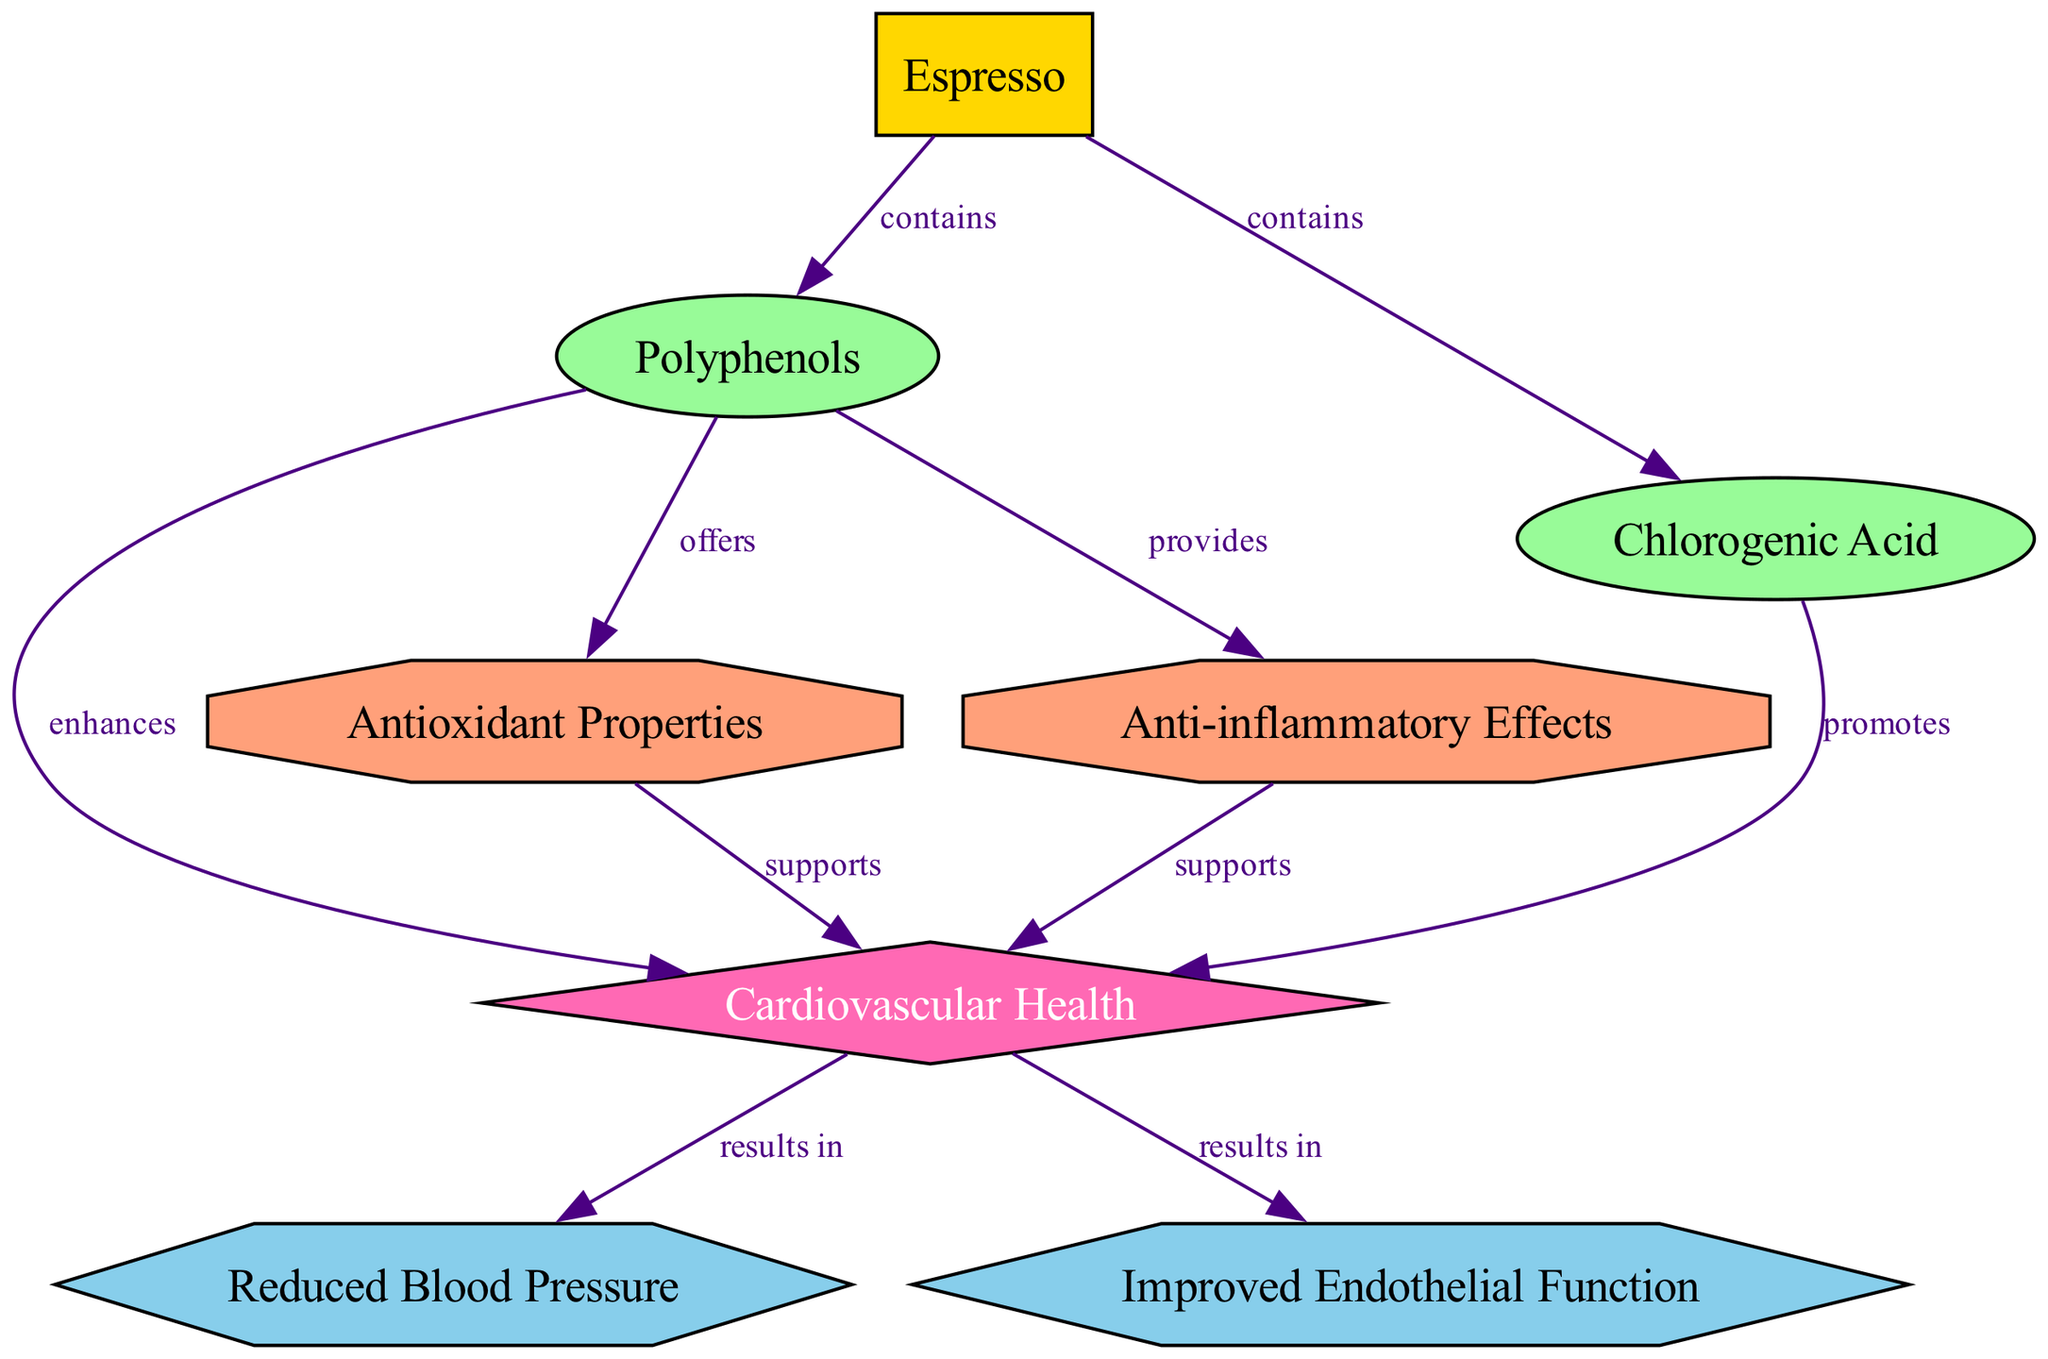What food contains polyphenols? The diagram shows that "Espresso" is the food that contains "Polyphenols." There is a direct edge labeled "contains" from the node "Espresso" to the node "Polyphenols."
Answer: Espresso How many benefits are associated with cardiovascular health? The diagram lists two benefits associated with cardiovascular health: "Reduced Blood Pressure" and "Improved Endothelial Function." This can be counted visually in the diagram.
Answer: 2 What compound in espresso promotes cardiovascular health? The diagram indicates that "Chlorogenic Acid" promotes cardiovascular health, as shown by the edge from "Chlorogenic Acid" to "Cardiovascular Health" labeled "promotes."
Answer: Chlorogenic Acid Which mechanism offered by polyphenols supports cardiovascular health? The mechanism "Antioxidant Properties" and "Anti-inflammatory Effects," are shown to support cardiovascular health indicated by edges connecting to the "Cardiovascular Health" node labeled "supports."
Answer: Antioxidant Properties and Anti-inflammatory Effects What is the relationship between polyphenols and cardiovascular health? According to the diagram, the relationship is that polyphenols enhance cardiovascular health, as shown by the edge labeled "enhances" from "Polyphenols" to "Cardiovascular Health."
Answer: Enhances 